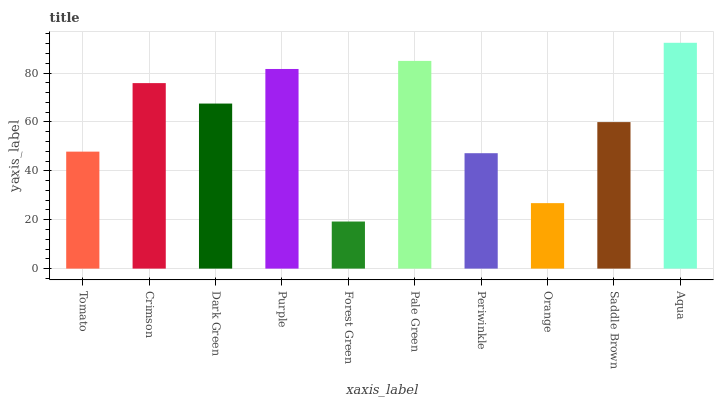Is Forest Green the minimum?
Answer yes or no. Yes. Is Aqua the maximum?
Answer yes or no. Yes. Is Crimson the minimum?
Answer yes or no. No. Is Crimson the maximum?
Answer yes or no. No. Is Crimson greater than Tomato?
Answer yes or no. Yes. Is Tomato less than Crimson?
Answer yes or no. Yes. Is Tomato greater than Crimson?
Answer yes or no. No. Is Crimson less than Tomato?
Answer yes or no. No. Is Dark Green the high median?
Answer yes or no. Yes. Is Saddle Brown the low median?
Answer yes or no. Yes. Is Forest Green the high median?
Answer yes or no. No. Is Tomato the low median?
Answer yes or no. No. 